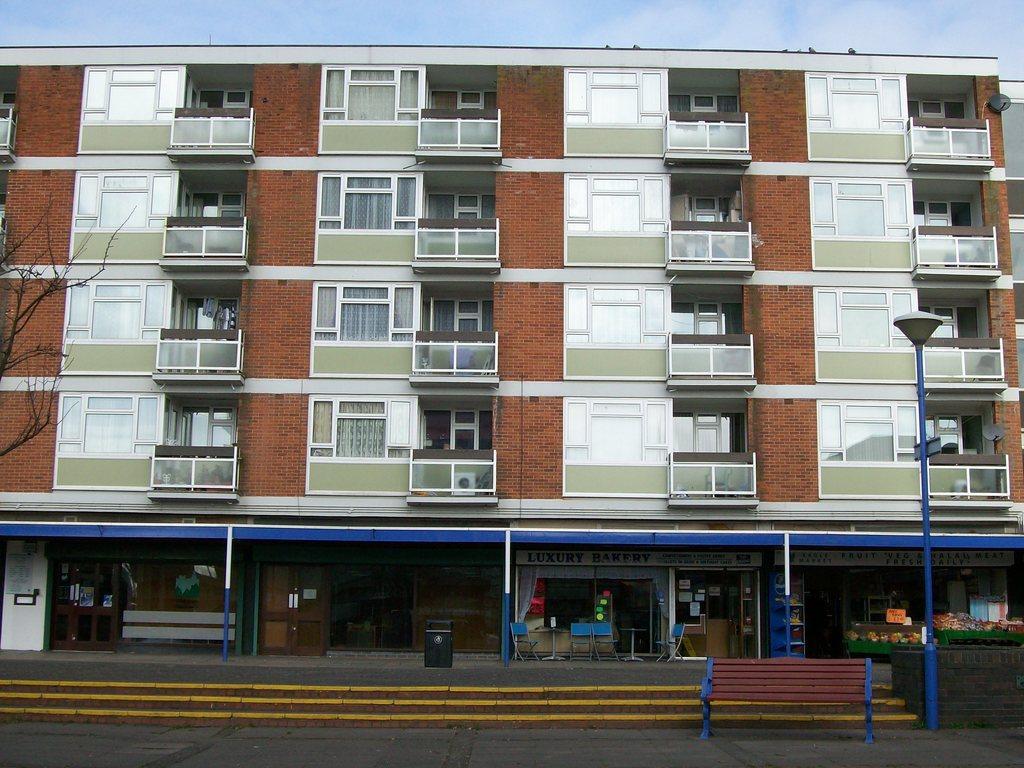In one or two sentences, can you explain what this image depicts? This is the picture of a building to which there are some widows, grills and also we can see something's arranged and a pole which has a lamp. 